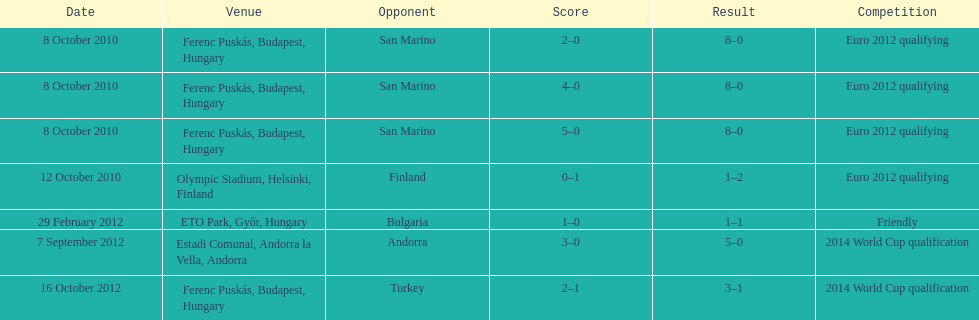What is the total number of international goals ádám szalai has made? 7. 